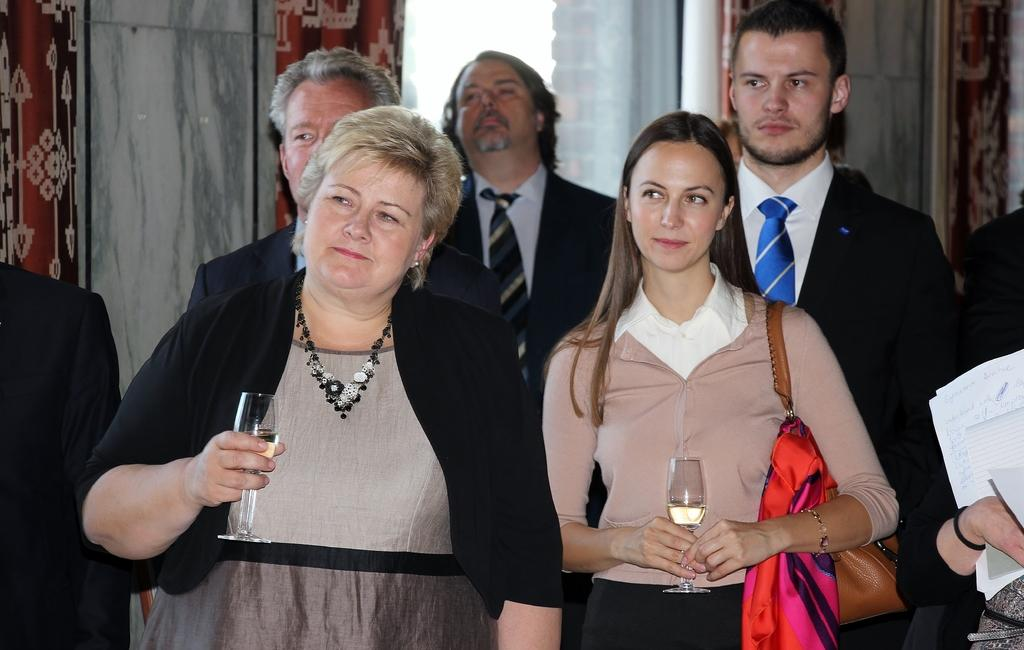How many women are in the image? There are two women in the image. What are the women holding in their hands? The women are holding glasses of alcohol. Can you describe the people behind the women? There are other persons visible behind the women. What can be seen in the background of the image? Curtains are visible in the background of the image. What type of slope can be seen in the image? There is no slope present in the image. How does the account balance look in the image? There is no account or balance information visible in the image. 